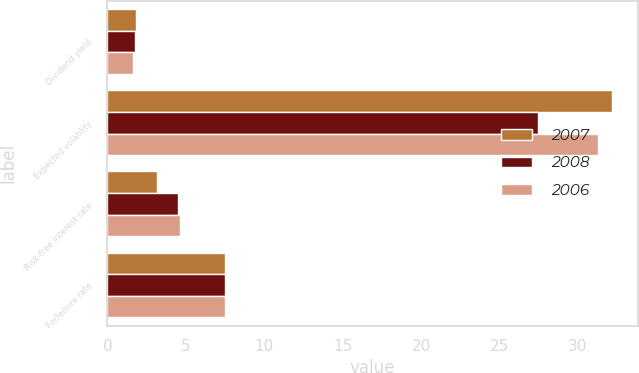<chart> <loc_0><loc_0><loc_500><loc_500><stacked_bar_chart><ecel><fcel>Dividend yield<fcel>Expected volatility<fcel>Risk-free interest rate<fcel>Forfeiture rate<nl><fcel>2007<fcel>1.8<fcel>32.2<fcel>3.15<fcel>7.5<nl><fcel>2008<fcel>1.78<fcel>27.43<fcel>4.51<fcel>7.5<nl><fcel>2006<fcel>1.64<fcel>31.29<fcel>4.6<fcel>7.5<nl></chart> 